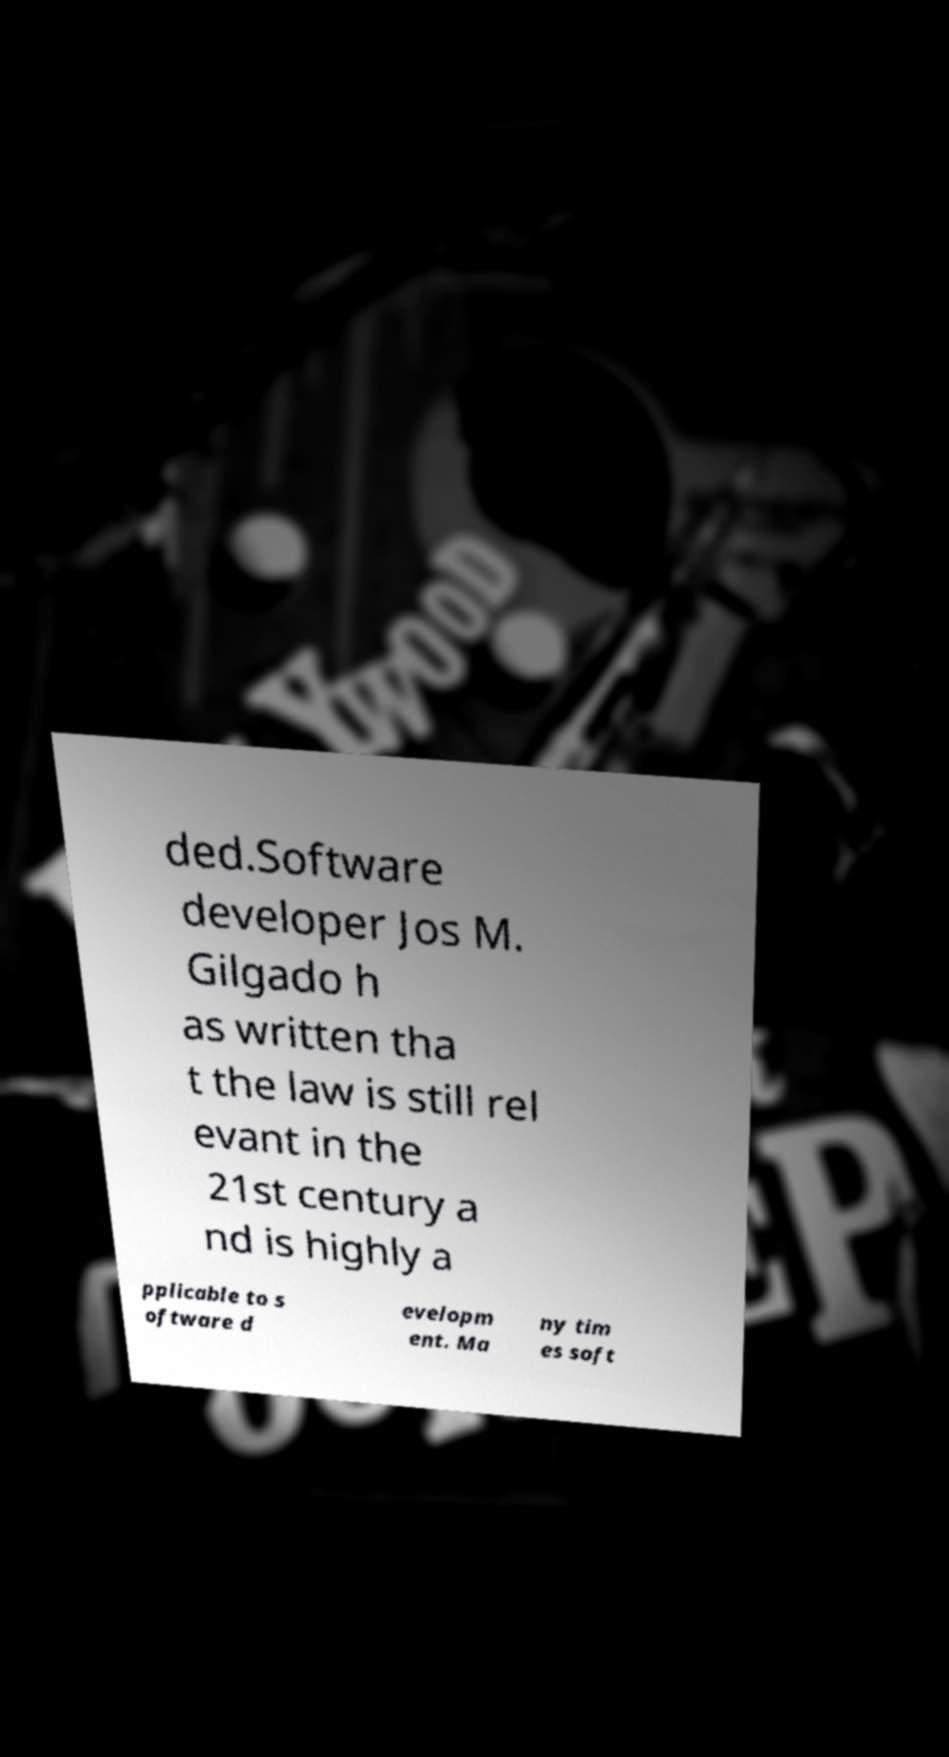For documentation purposes, I need the text within this image transcribed. Could you provide that? ded.Software developer Jos M. Gilgado h as written tha t the law is still rel evant in the 21st century a nd is highly a pplicable to s oftware d evelopm ent. Ma ny tim es soft 